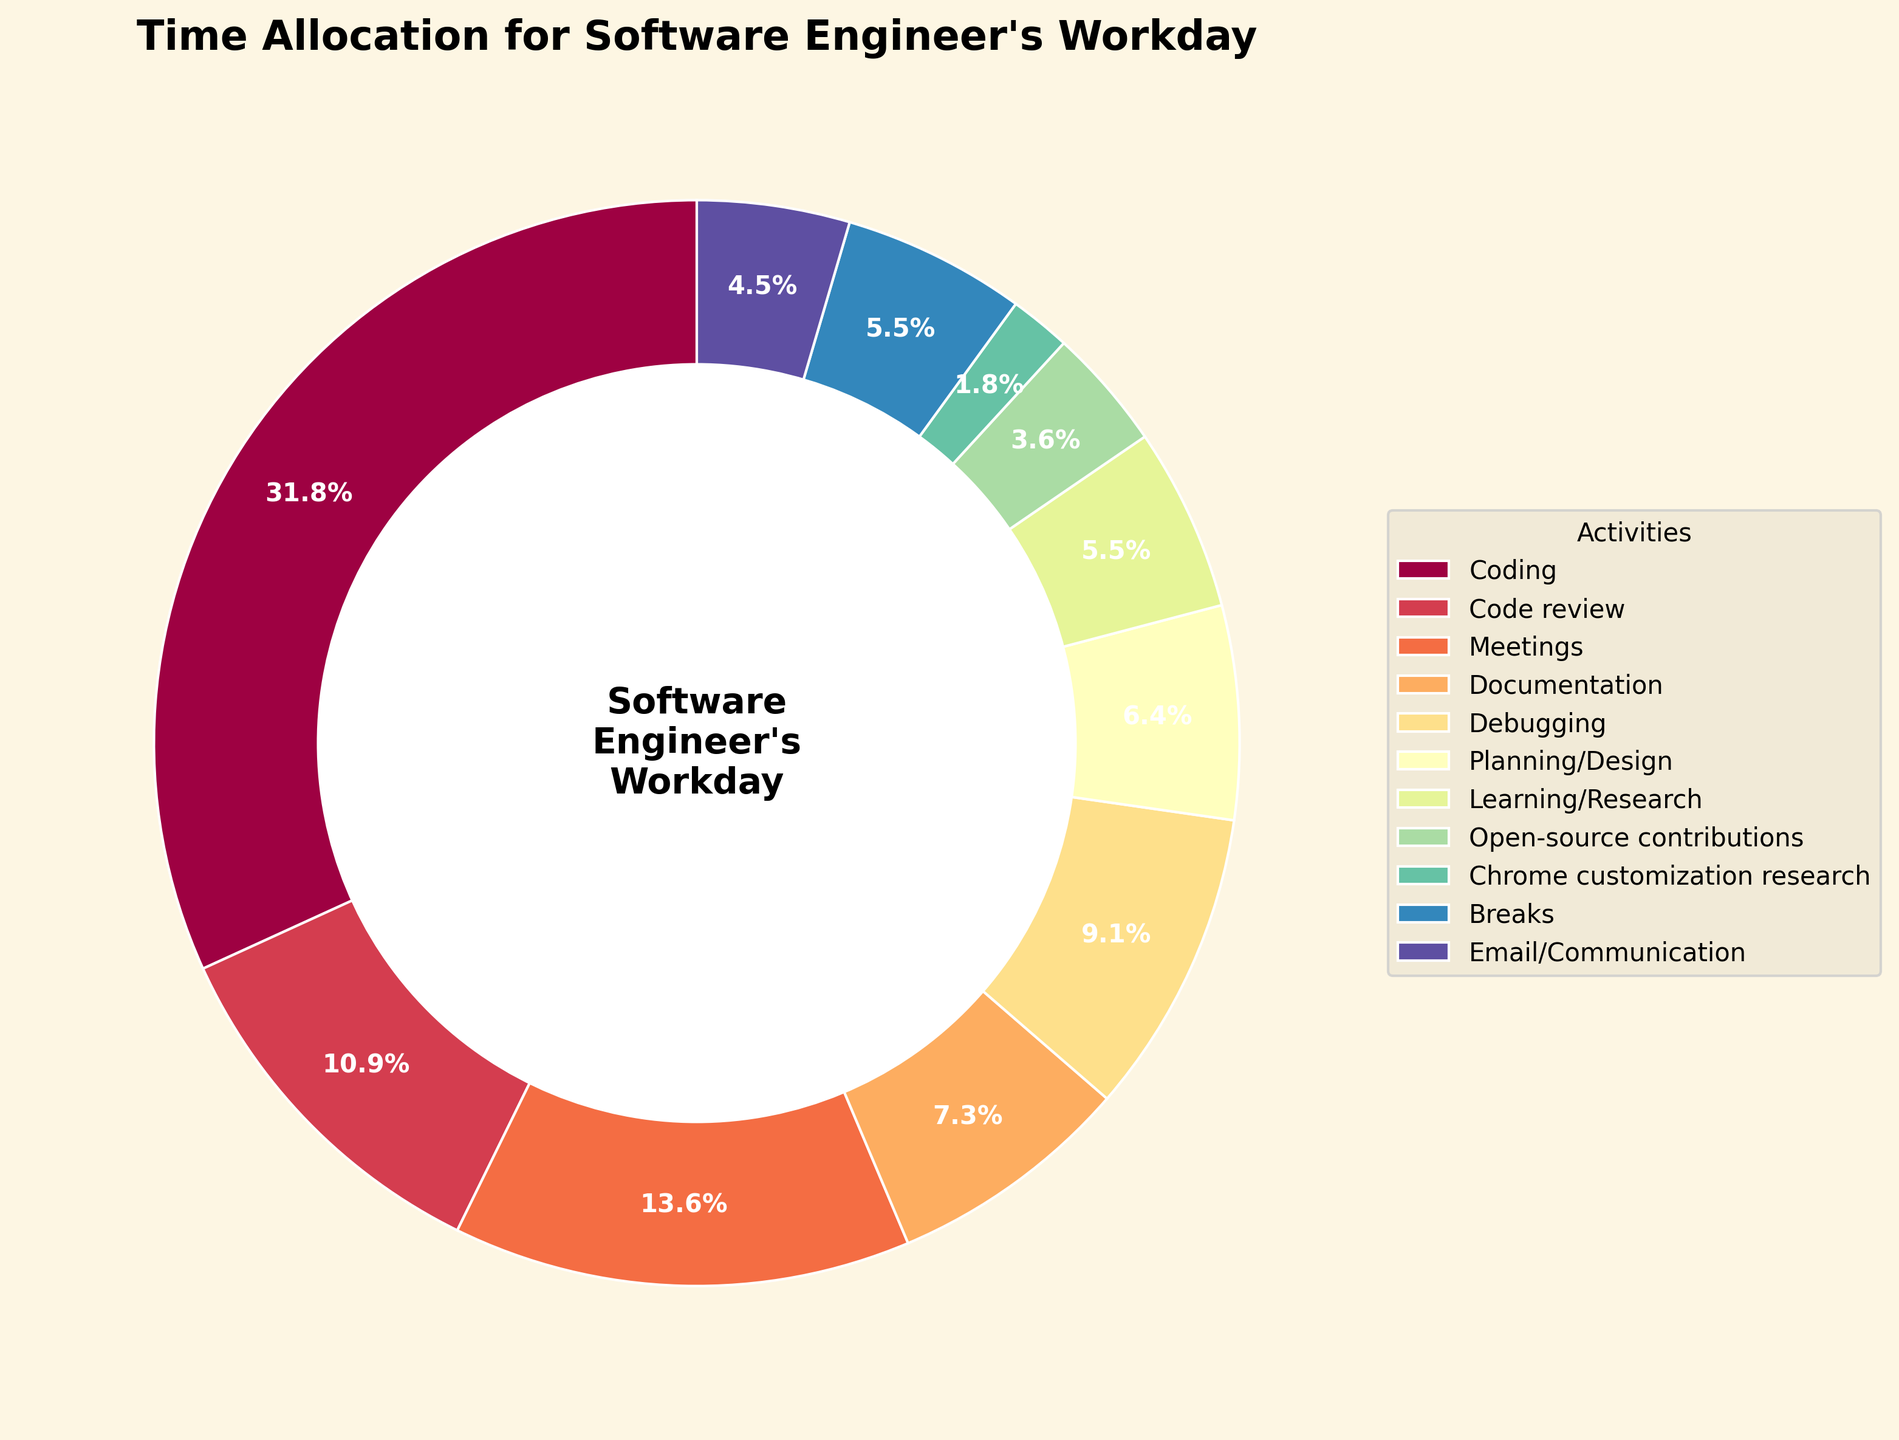Which activity takes up the largest portion of time? The largest portion can be found by looking at the segment with the largest percentage in the pie chart. In this case, "Coding" is the largest portion with 35%.
Answer: Coding How much time is spent on Coding and Code review combined? To find the combined time, add the percentages of "Coding" and "Code review". This is 35% + 12% = 47%.
Answer: 47% What is the difference in time allocation between Meetings and Debugging? To find the difference, subtract the percentage of "Debugging" from "Meetings". This is 15% - 10% = 5%.
Answer: 5% Which takes up more time, Learning/Research or Breaks? Compare the percentages of "Learning/Research" and "Breaks". "Learning/Research" is 6% whereas "Breaks" is also 6%. They take up the same time.
Answer: Same What fraction of the workday is allocated to Planning/Design compared to Coding? To find the fraction, divide the percentage of "Planning/Design" by "Coding". This is 7% / 35% = 0.2. So, Planning/Design takes up 1/5 the time of Coding.
Answer: 1/5 What proportion of the workday is spent on Documentation? The proportion can be directly found by looking at the percentage of "Documentation" in the pie chart, which is 8%.
Answer: 8% Are more time spent on Email/Communication or Chrome customization research? Compare the percentages of "Email/Communication" and "Chrome customization research". "Email/Communication" is 5% whereas "Chrome customization research" is 2%. Thus, more time is spent on "Email/Communication".
Answer: Email/Communication What percentage of time is spent on activities other than Coding and Meetings? Subtract the combined percentage of "Coding" and "Meetings" from 100%. This is 100% - (35% + 15%) = 50%.
Answer: 50% Which sections of the pie chart have the three smallest allocations, and what are their combined percentage? Identify the three activities with the smallest percentages: "Open-source contributions" (4%), "Chrome customization research" (2%), and "Learning/Research" (6%). Add these up: 4% + 2% + 6% = 12%.
Answer: Open-source contributions, Chrome customization research, Learning/Research; 12% Is the time allocated for Documentation more than Planning/Design and Meetings combined? Add the percentages of "Planning/Design" and "Meetings". This is 7% + 15% = 22%. Compare this to "Documentation" which is 8%. Since 8% is less than 22%, Documentation takes up less time.
Answer: No 